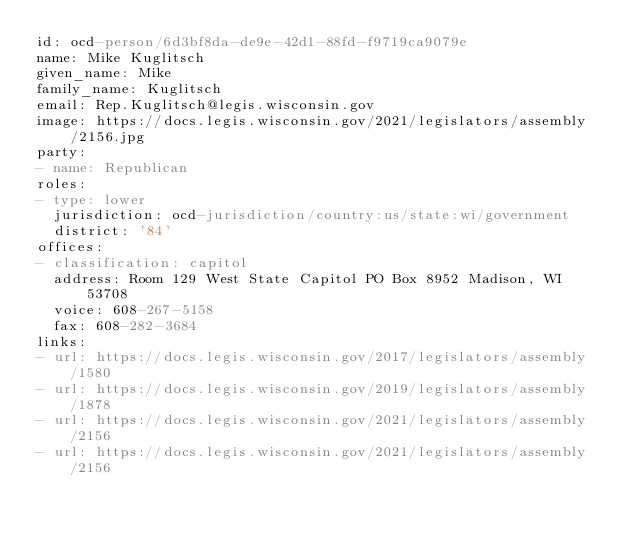Convert code to text. <code><loc_0><loc_0><loc_500><loc_500><_YAML_>id: ocd-person/6d3bf8da-de9e-42d1-88fd-f9719ca9079e
name: Mike Kuglitsch
given_name: Mike
family_name: Kuglitsch
email: Rep.Kuglitsch@legis.wisconsin.gov
image: https://docs.legis.wisconsin.gov/2021/legislators/assembly/2156.jpg
party:
- name: Republican
roles:
- type: lower
  jurisdiction: ocd-jurisdiction/country:us/state:wi/government
  district: '84'
offices:
- classification: capitol
  address: Room 129 West State Capitol PO Box 8952 Madison, WI 53708
  voice: 608-267-5158
  fax: 608-282-3684
links:
- url: https://docs.legis.wisconsin.gov/2017/legislators/assembly/1580
- url: https://docs.legis.wisconsin.gov/2019/legislators/assembly/1878
- url: https://docs.legis.wisconsin.gov/2021/legislators/assembly/2156
- url: https://docs.legis.wisconsin.gov/2021/legislators/assembly/2156</code> 